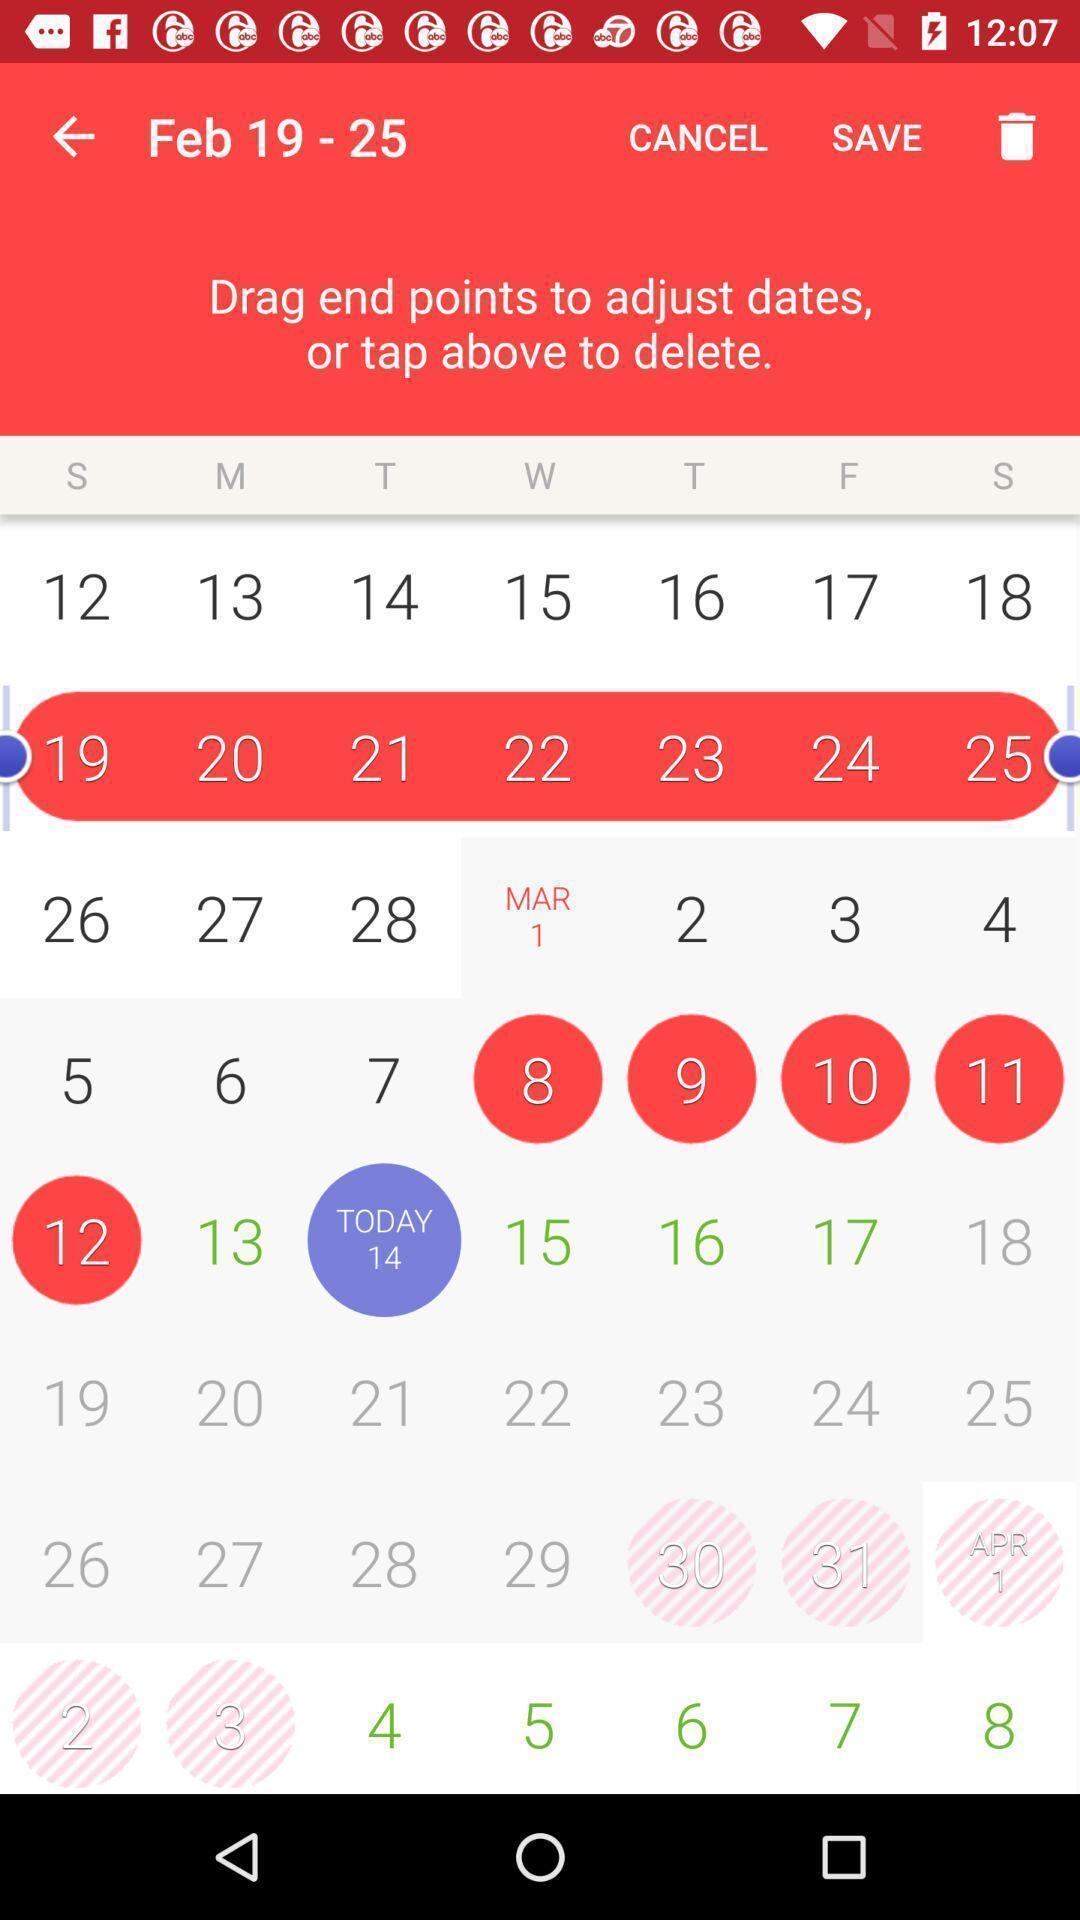Give me a narrative description of this picture. Screen displaying the calendar to select dates. 